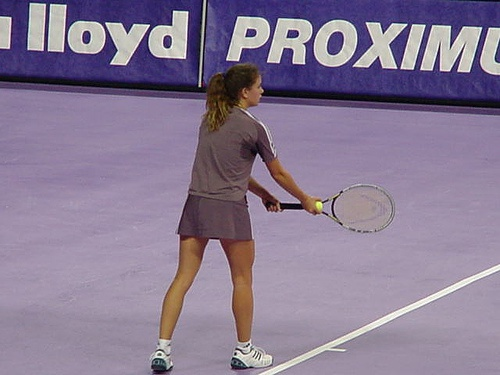Describe the objects in this image and their specific colors. I can see people in navy, brown, gray, maroon, and black tones, tennis racket in navy, darkgray, gray, and black tones, and sports ball in navy, olive, khaki, and darkgray tones in this image. 